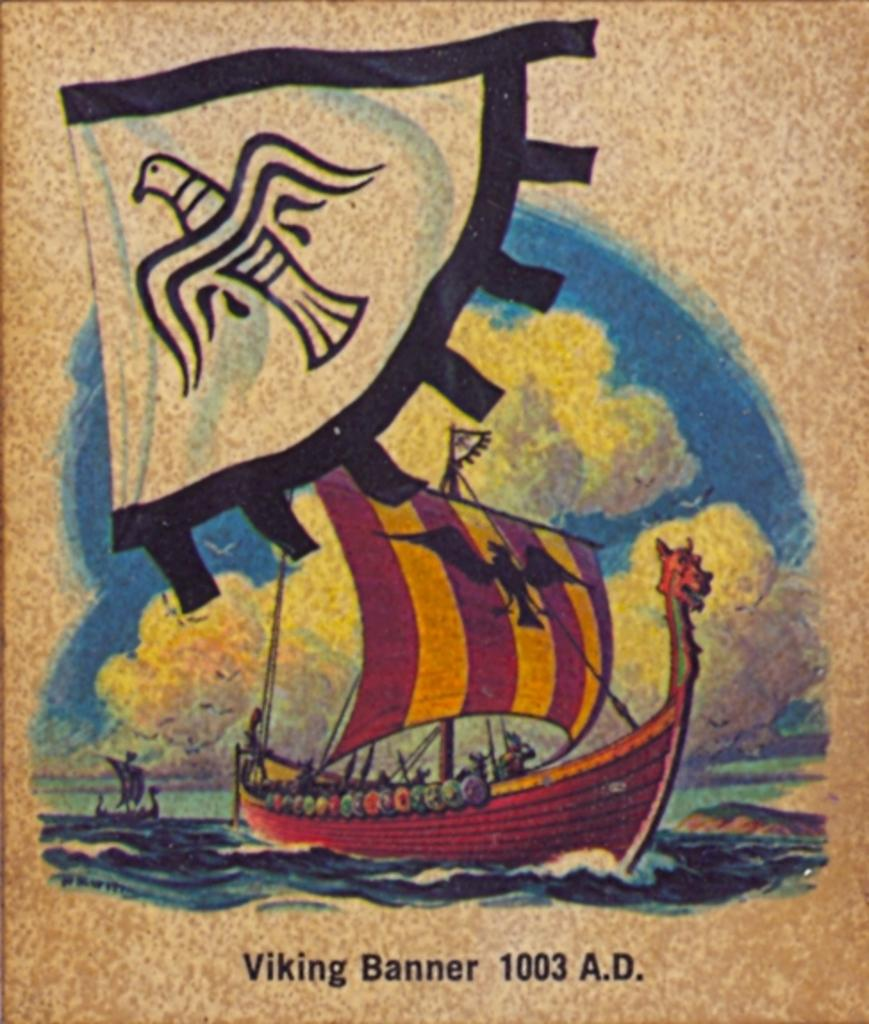<image>
Present a compact description of the photo's key features. A picture of a Viking ship that says Viking Banner 1003 A.D. 